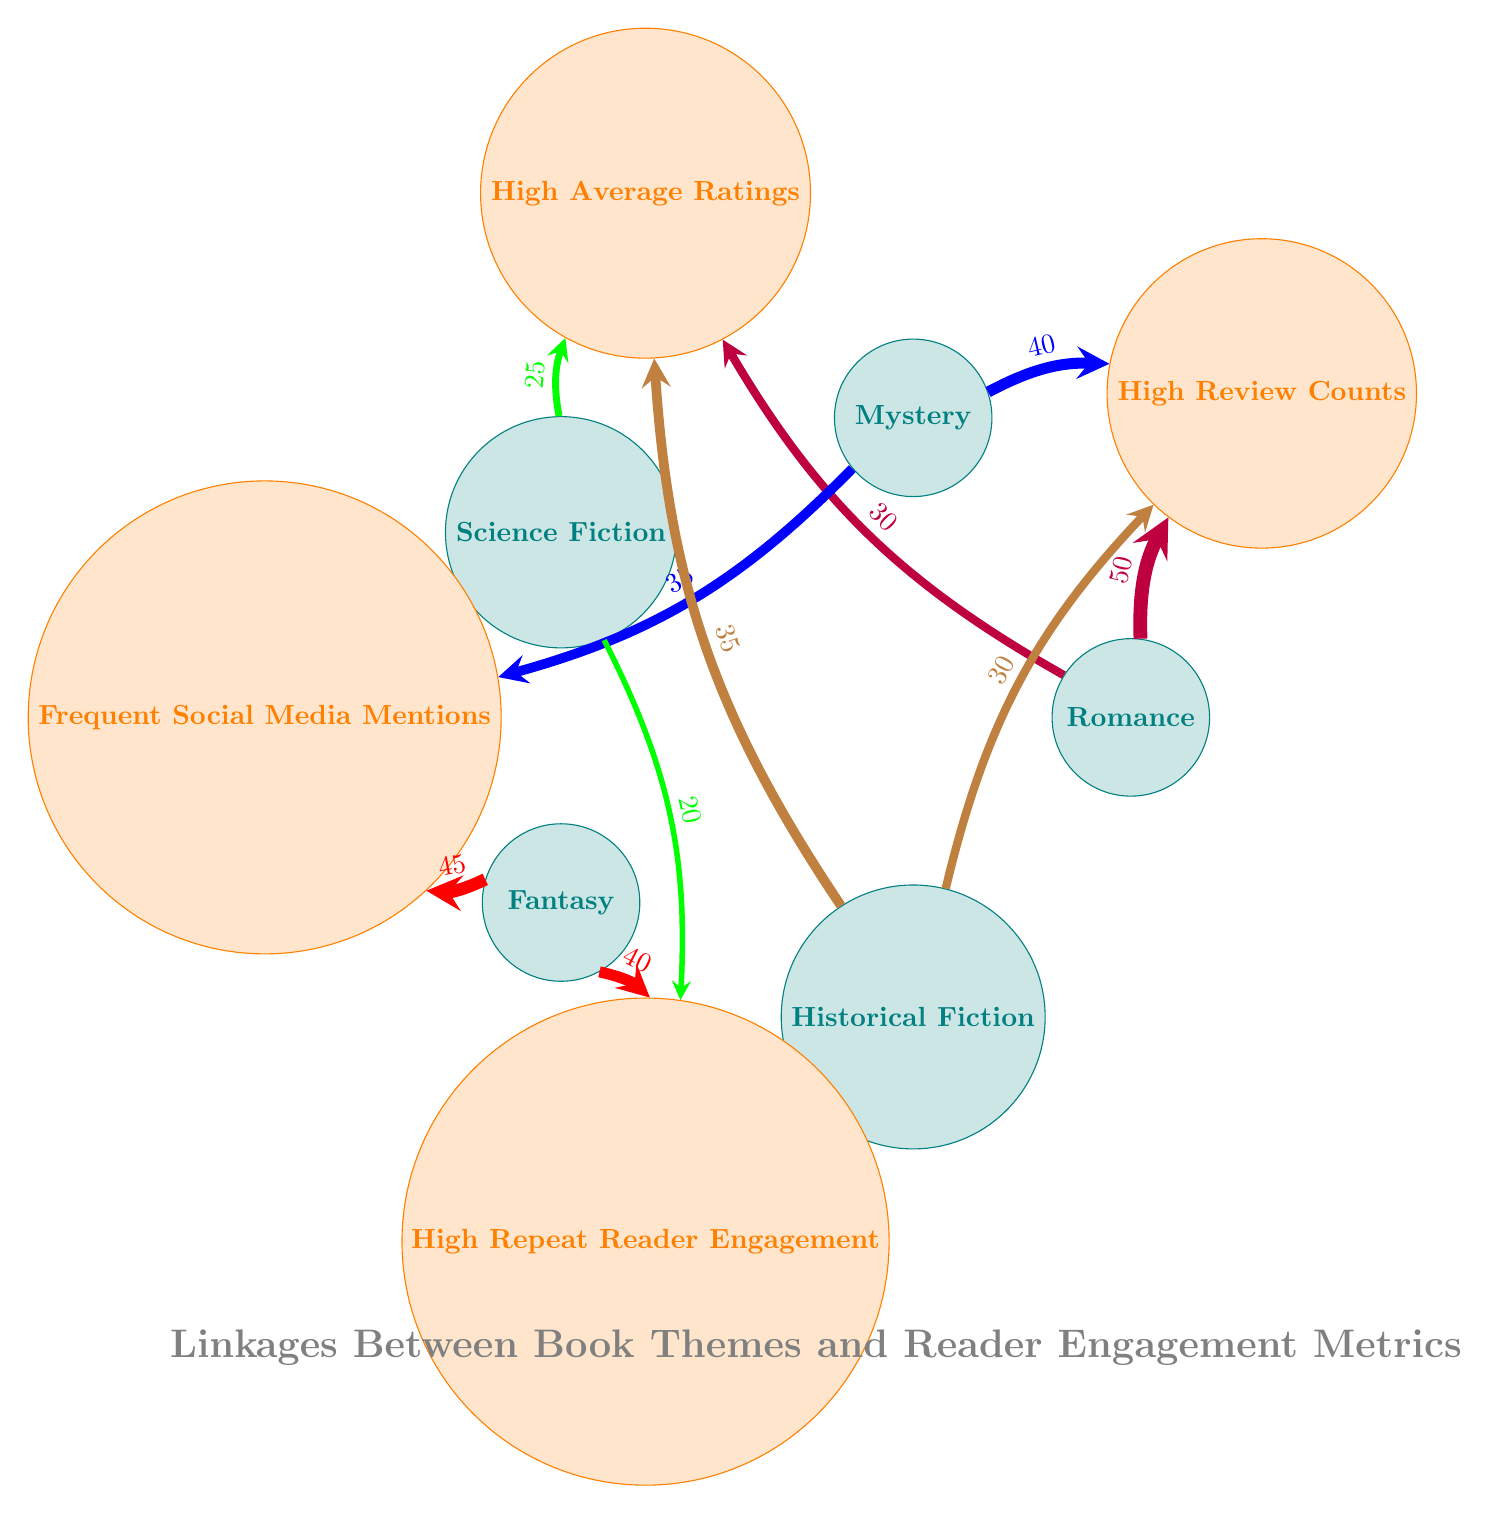What are the two themes linked to high review counts? In the diagram, high review counts are connected to the themes Romance and Mystery. I can see connections from Romance with a value of 50 and from Mystery with a value of 40.
Answer: Romance, Mystery What is the highest value link for the theme Fantasy? The connections for Fantasy show that it has two links: Frequent Social Media Mentions with a value of 45 and High Repeat Reader Engagement with a value of 40. The highest value among these is 45.
Answer: 45 How many total themes are represented in the diagram? The diagram includes five distinct themes: Romance, Mystery, Science Fiction, Fantasy, and Historical Fiction. Counting these themes gives a total of five.
Answer: 5 Which theme has the highest average ratings linkage? The connections related to High Average Ratings show that Historical Fiction has a value of 35, the highest amongst all themes with ratings connections, compared to Romance (30) and Science Fiction (25).
Answer: Historical Fiction Is there any theme linked to High Repeat Reader Engagement? The theme Science Fiction and Fantasy are both linked to High Repeat Reader Engagement. Science Fiction has a value of 20 and Fantasy has a higher linkage value of 40.
Answer: Yes What is the total number of connections depicted in the diagram? The diagram lists connections between themes and metrics. Counting each connection results in a total of ten connections represented.
Answer: 10 Which theme has the least engagement in terms of average ratings? The connections indicate that Science Fiction has the lowest value for High Average Ratings, with a value of 25, making it the least among the themes compared.
Answer: Science Fiction What linkage connects Romance and ratings, and what is its value? The link from Romance to High Average Ratings is made with a value of 30, indicating a strong connection. Thus, Romance has an established connection to ratings.
Answer: 30 